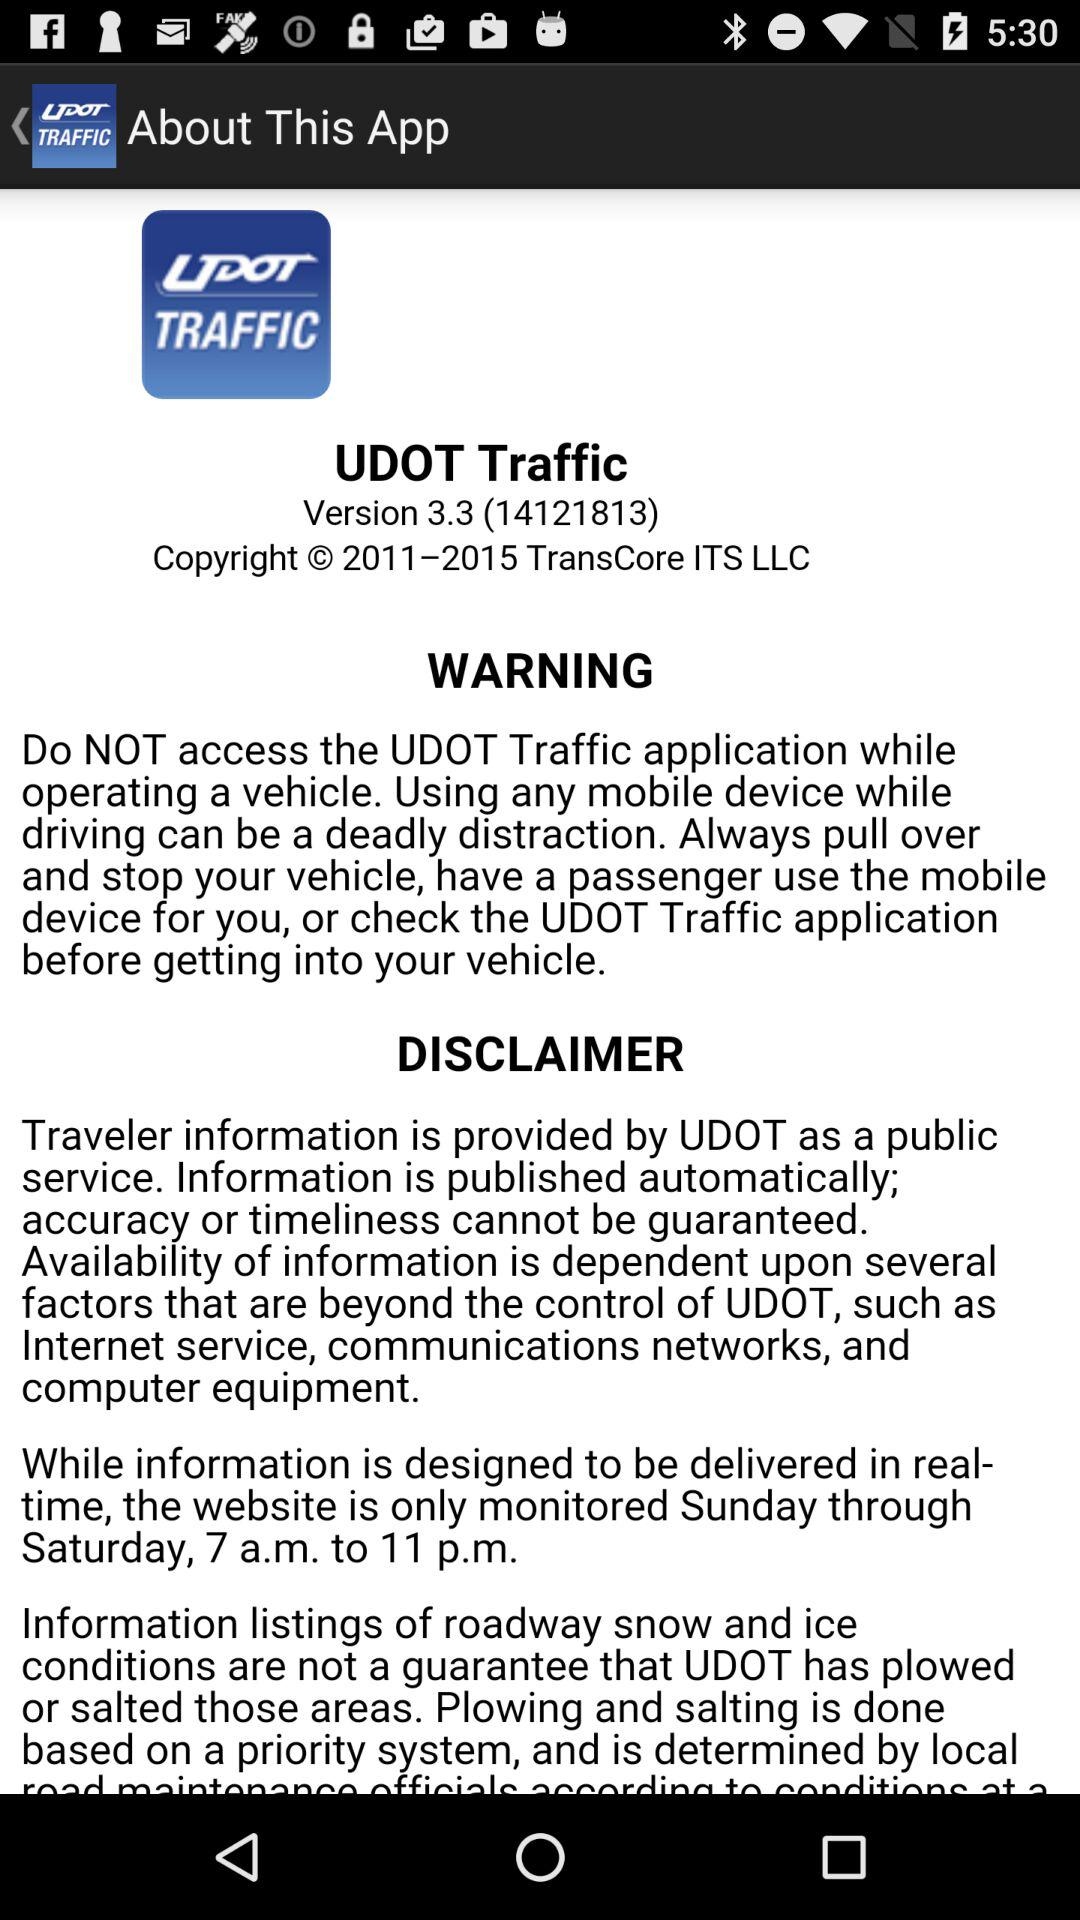At what time is the information designed to be delivered? The information is designed to be delivered in real-time. 